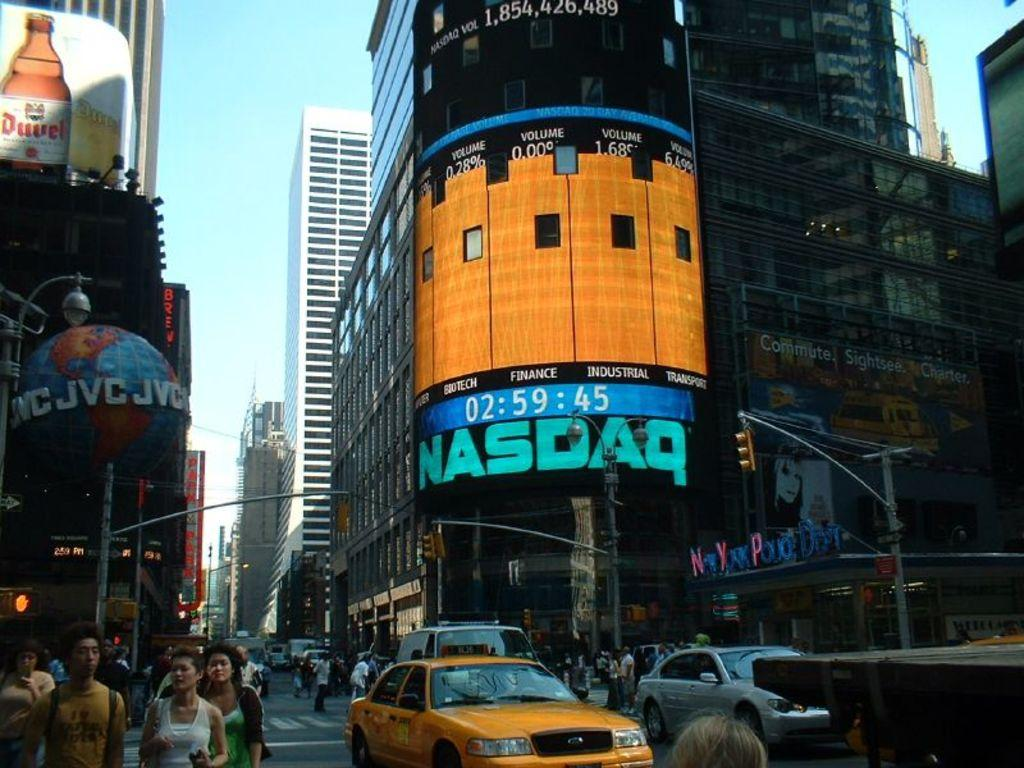<image>
Create a compact narrative representing the image presented. A view of the Nasdaq screen on a building in Times Square. 